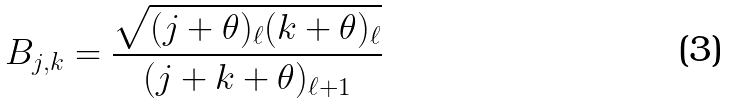Convert formula to latex. <formula><loc_0><loc_0><loc_500><loc_500>B _ { j , k } = \frac { \sqrt { ( j + \theta ) _ { \ell } ( k + \theta ) _ { \ell } } } { ( j + k + \theta ) _ { \ell + 1 } }</formula> 